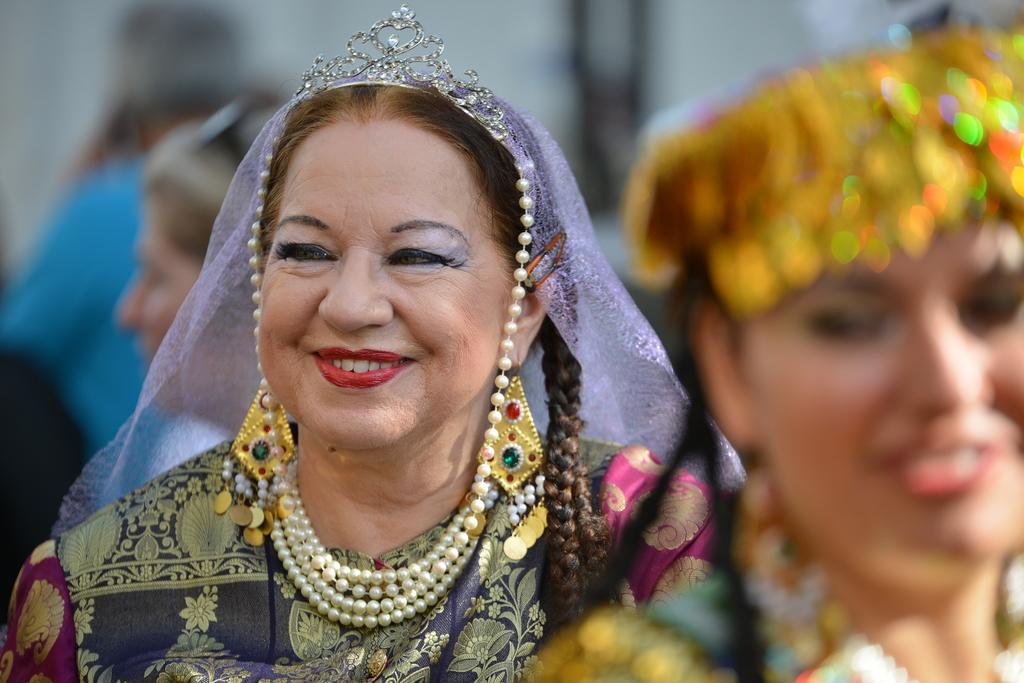Who is present in the image? There are women in the image. What is the facial expression of the women? The women are smiling. What type of accessories are the women wearing? The women are wearing jewellery, specifically necklaces and other ornaments. Can you describe the background of the image? The background of the image is blurred. What type of tail can be seen on the women in the image? There are no tails visible on the women in the image. What class are the women attending in the image? There is no indication of a class or educational setting in the image. 